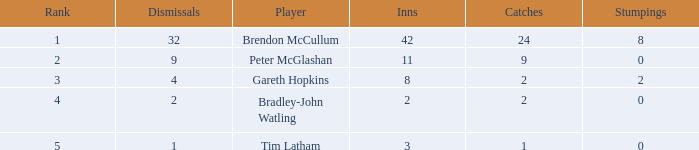How many dismissals did the player Peter McGlashan have? 9.0. 